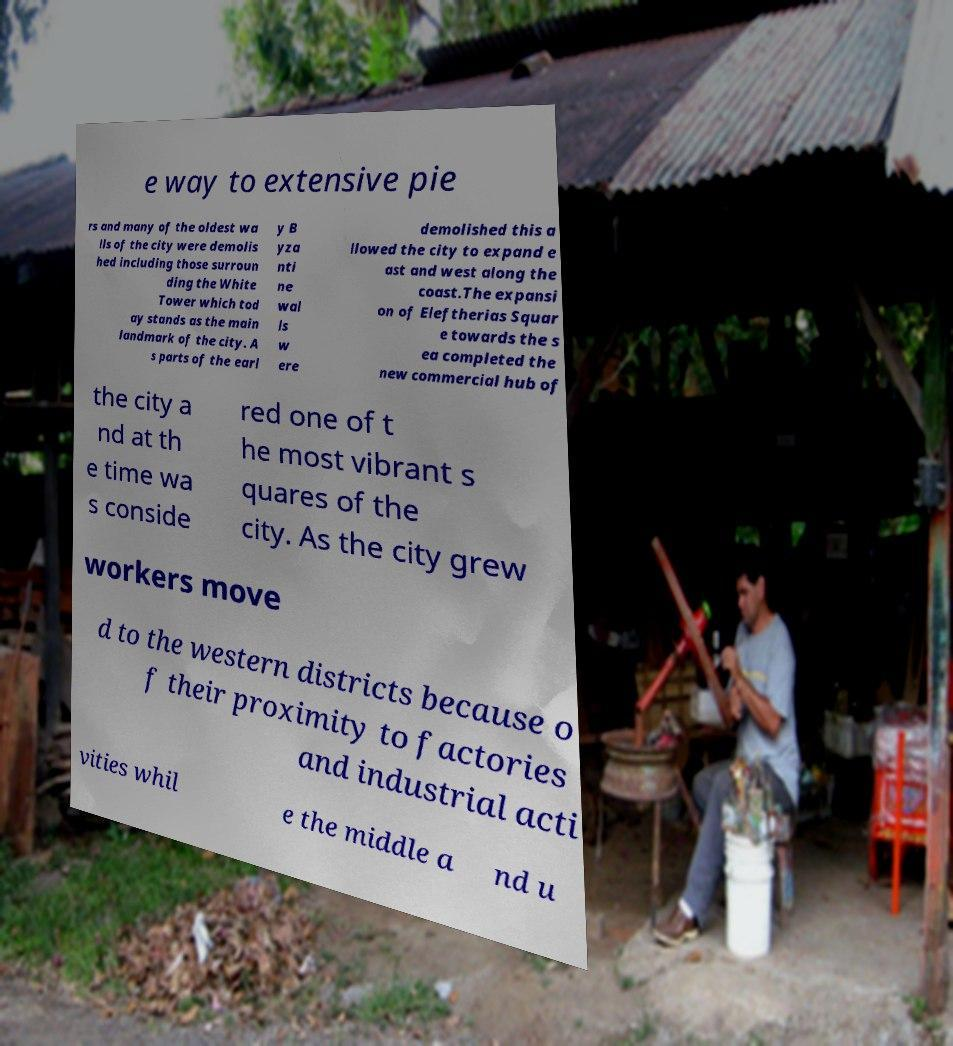Could you extract and type out the text from this image? e way to extensive pie rs and many of the oldest wa lls of the city were demolis hed including those surroun ding the White Tower which tod ay stands as the main landmark of the city. A s parts of the earl y B yza nti ne wal ls w ere demolished this a llowed the city to expand e ast and west along the coast.The expansi on of Eleftherias Squar e towards the s ea completed the new commercial hub of the city a nd at th e time wa s conside red one of t he most vibrant s quares of the city. As the city grew workers move d to the western districts because o f their proximity to factories and industrial acti vities whil e the middle a nd u 